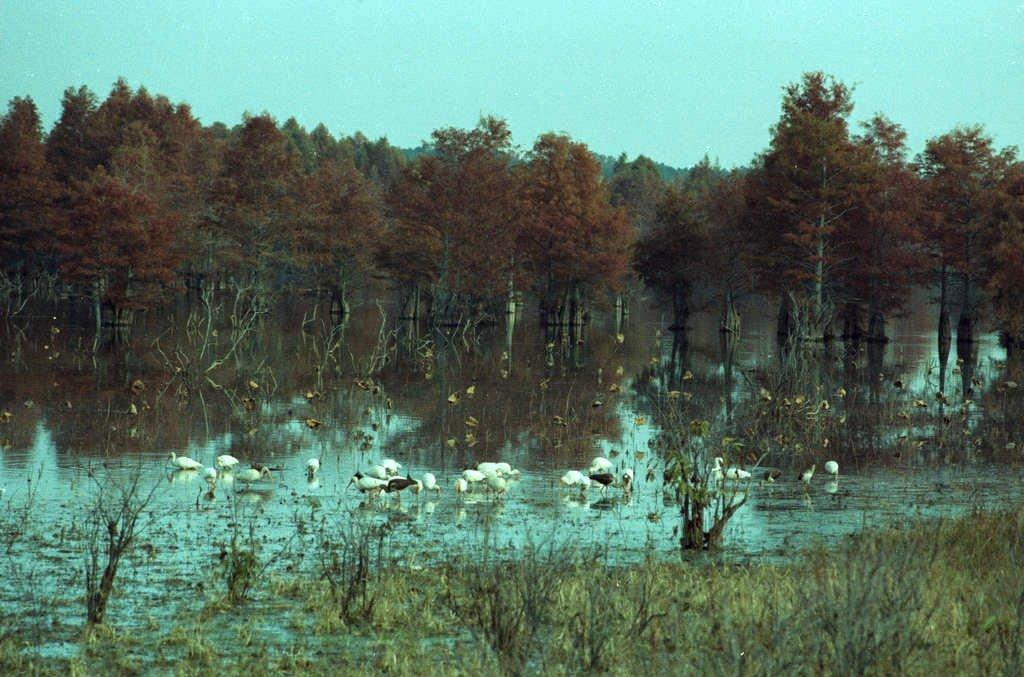What type of animals can be seen on the surface of the water in the image? There are birds on the surface of the water in the image. What type of vegetation is visible in the image? There is grass visible in the image, and there are also trees. What is visible at the top of the image? The sky is visible at the top of the image. Where is the trail leading to the zoo in the image? There is no trail or zoo present in the image; it features birds on the surface of the water, grass, trees, and the sky. What type of blade is being used by the birds in the image? There are no blades present in the image; the birds are simply floating on the water's surface. 